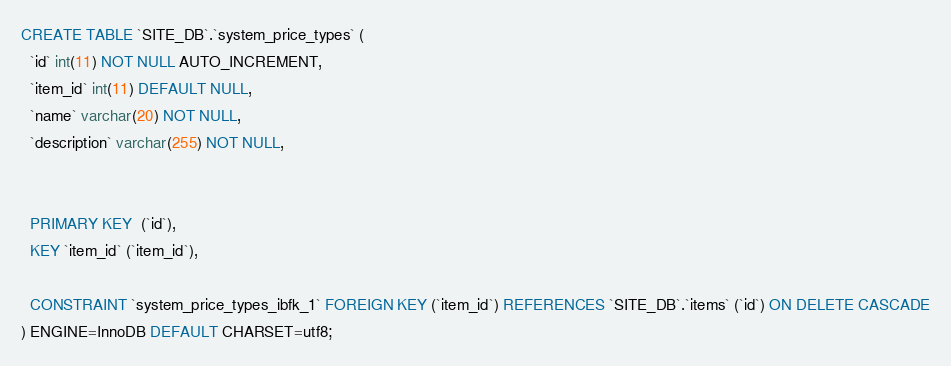<code> <loc_0><loc_0><loc_500><loc_500><_SQL_>CREATE TABLE `SITE_DB`.`system_price_types` (
  `id` int(11) NOT NULL AUTO_INCREMENT,
  `item_id` int(11) DEFAULT NULL,
  `name` varchar(20) NOT NULL,
  `description` varchar(255) NOT NULL,


  PRIMARY KEY  (`id`),
  KEY `item_id` (`item_id`),
  
  CONSTRAINT `system_price_types_ibfk_1` FOREIGN KEY (`item_id`) REFERENCES `SITE_DB`.`items` (`id`) ON DELETE CASCADE
) ENGINE=InnoDB DEFAULT CHARSET=utf8;
</code> 